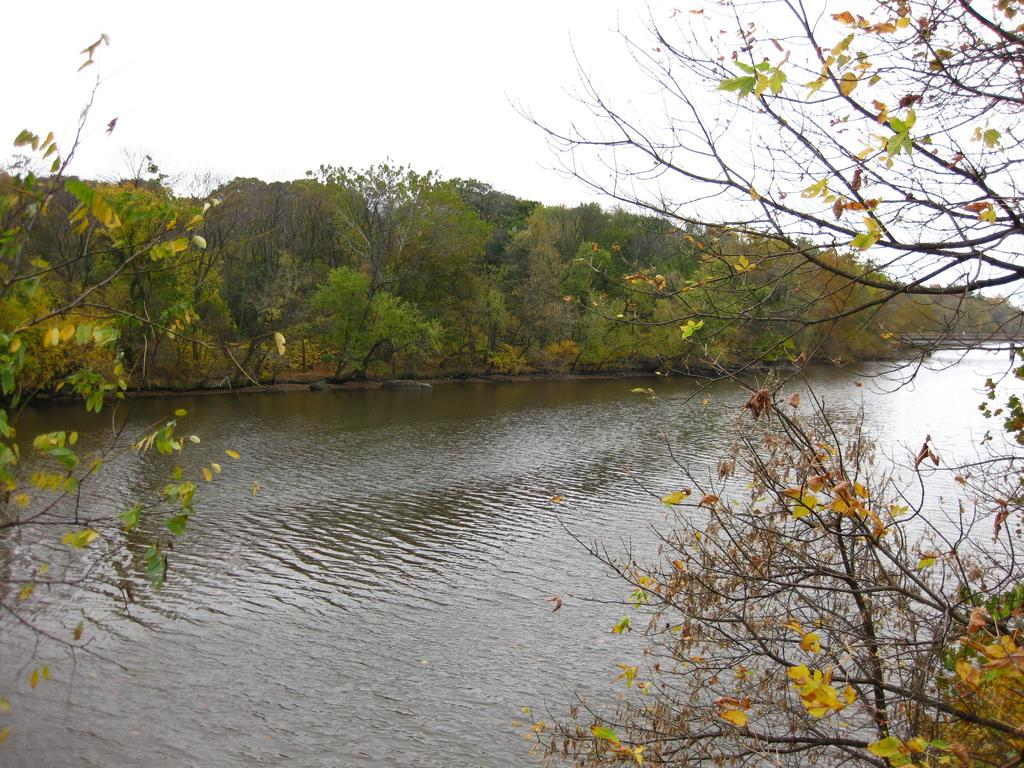What type of vegetation can be seen in the image? There are trees in the image. What is located in the middle of the trees? There is a water body in the middle of the trees. What can be seen in the background of the image? The sky is visible in the background of the image. What type of wool clothing is being worn by the insect in the image? There are no insects or wool clothing present in the image. Is the water body in the image frozen due to winter conditions? The image does not provide information about the season or temperature, so it cannot be determined if the water body is frozen. 